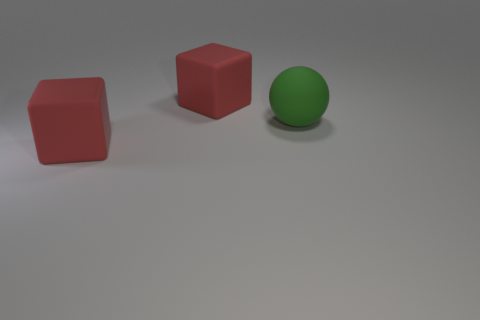How many objects are either things behind the green rubber sphere or small yellow cylinders?
Keep it short and to the point. 1. How many objects are big red matte cubes behind the green matte object or big red matte blocks behind the large green rubber sphere?
Your answer should be very brief. 1. Are there fewer big red matte blocks that are on the left side of the green ball than cubes?
Keep it short and to the point. No. Is the material of the green ball the same as the large object that is behind the big ball?
Make the answer very short. Yes. There is a cube that is to the right of the large red object in front of the red matte object behind the large green matte sphere; what is it made of?
Offer a very short reply. Rubber. There is a large object right of the large red cube behind the sphere; what color is it?
Your answer should be compact. Green. What number of red blocks are there?
Ensure brevity in your answer.  2. What number of metallic objects are big green objects or blue blocks?
Keep it short and to the point. 0. There is a red block on the left side of the red rubber block that is behind the green rubber ball; what is its material?
Provide a short and direct response. Rubber. How many green matte balls have the same size as the green object?
Your answer should be very brief. 0. 